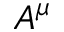Convert formula to latex. <formula><loc_0><loc_0><loc_500><loc_500>A ^ { \mu }</formula> 